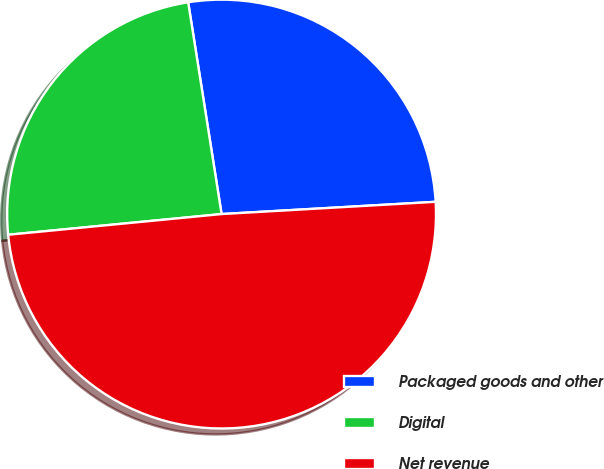<chart> <loc_0><loc_0><loc_500><loc_500><pie_chart><fcel>Packaged goods and other<fcel>Digital<fcel>Net revenue<nl><fcel>26.58%<fcel>24.05%<fcel>49.37%<nl></chart> 